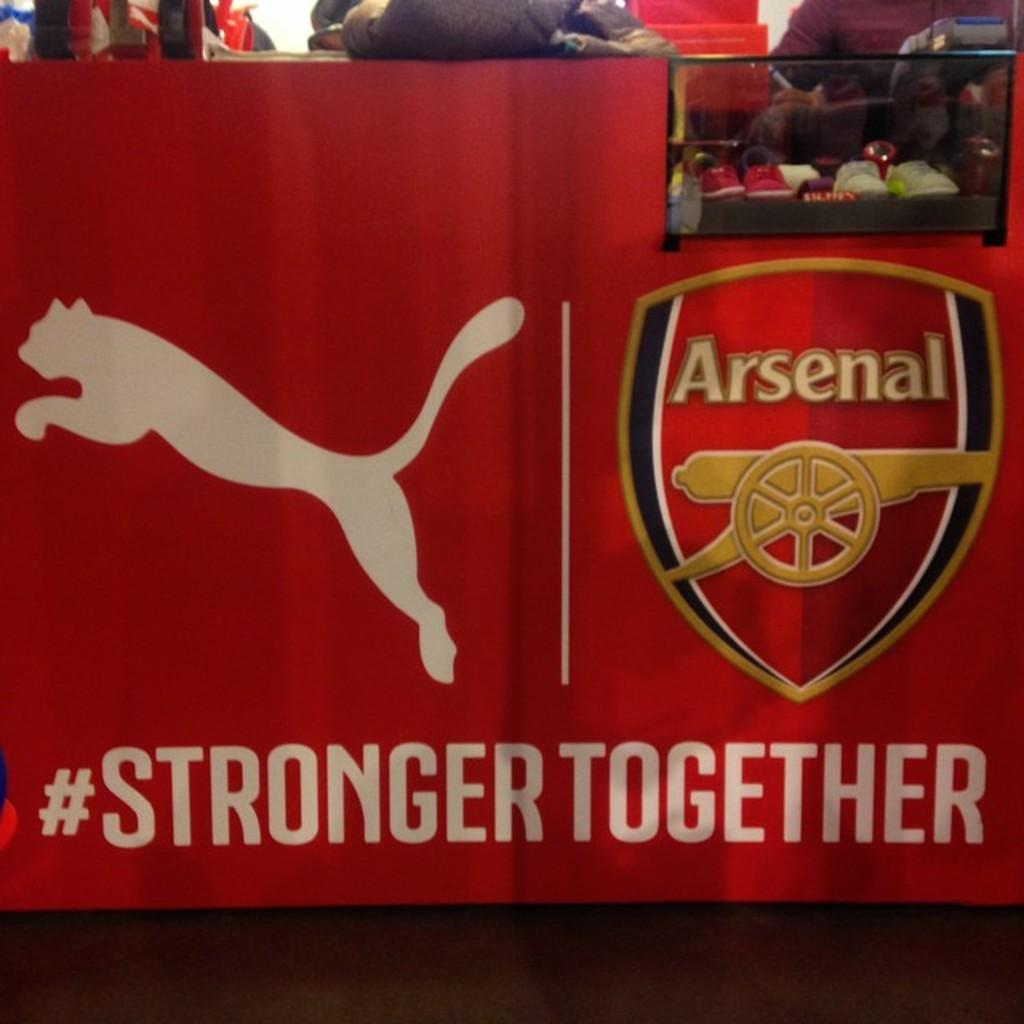Provide a one-sentence caption for the provided image. A Puma advertisement in the UK for Arsenal, a soccer team, with the hastag #STRONGERTOGETHER. 